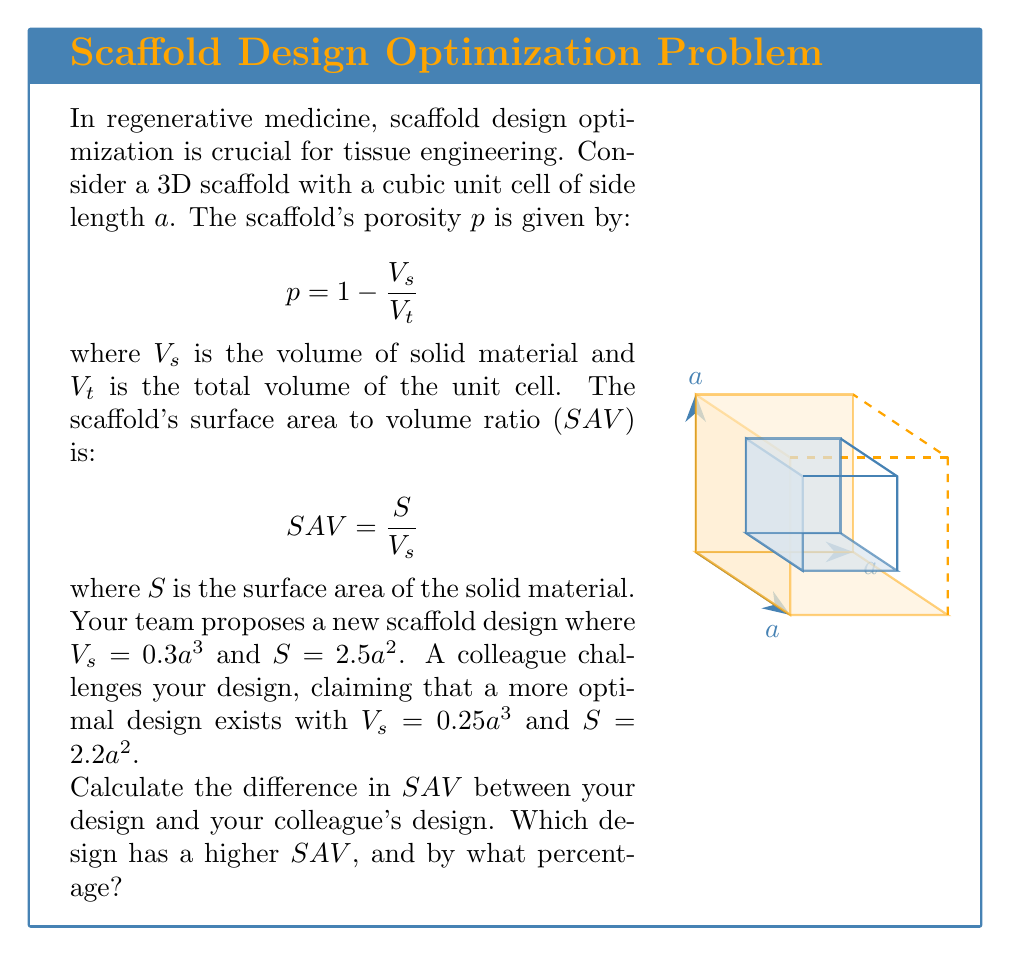Could you help me with this problem? Let's approach this step-by-step:

1) For our design:
   $V_s = 0.3a^3$
   $S = 2.5a^2$
   
   $SAV_{our} = \frac{S}{V_s} = \frac{2.5a^2}{0.3a^3} = \frac{25}{3a}$

2) For the colleague's design:
   $V_s = 0.25a^3$
   $S = 2.2a^2$
   
   $SAV_{colleague} = \frac{S}{V_s} = \frac{2.2a^2}{0.25a^3} = \frac{8.8}{a}$

3) The difference in $SAV$:
   $\Delta SAV = SAV_{our} - SAV_{colleague} = \frac{25}{3a} - \frac{8.8}{a} = \frac{25-26.4}{3a} = -\frac{0.467}{a}$

4) To determine which design has a higher $SAV$, we compare the values:
   $SAV_{our} = \frac{25}{3a} \approx 8.333/a$
   $SAV_{colleague} = \frac{8.8}{a} = 8.8/a$

   The colleague's design has a higher $SAV$.

5) To calculate the percentage difference:
   Percentage difference = $\frac{SAV_{colleague} - SAV_{our}}{SAV_{our}} \times 100\%$
   $= \frac{8.8/a - 25/(3a)}{25/(3a)} \times 100\%$
   $= \frac{26.4 - 25}{25} \times 100\% = 5.6\%$

Therefore, the colleague's design has a $5.6\%$ higher $SAV$ than our design.
Answer: The colleague's design has a 5.6% higher SAV. 